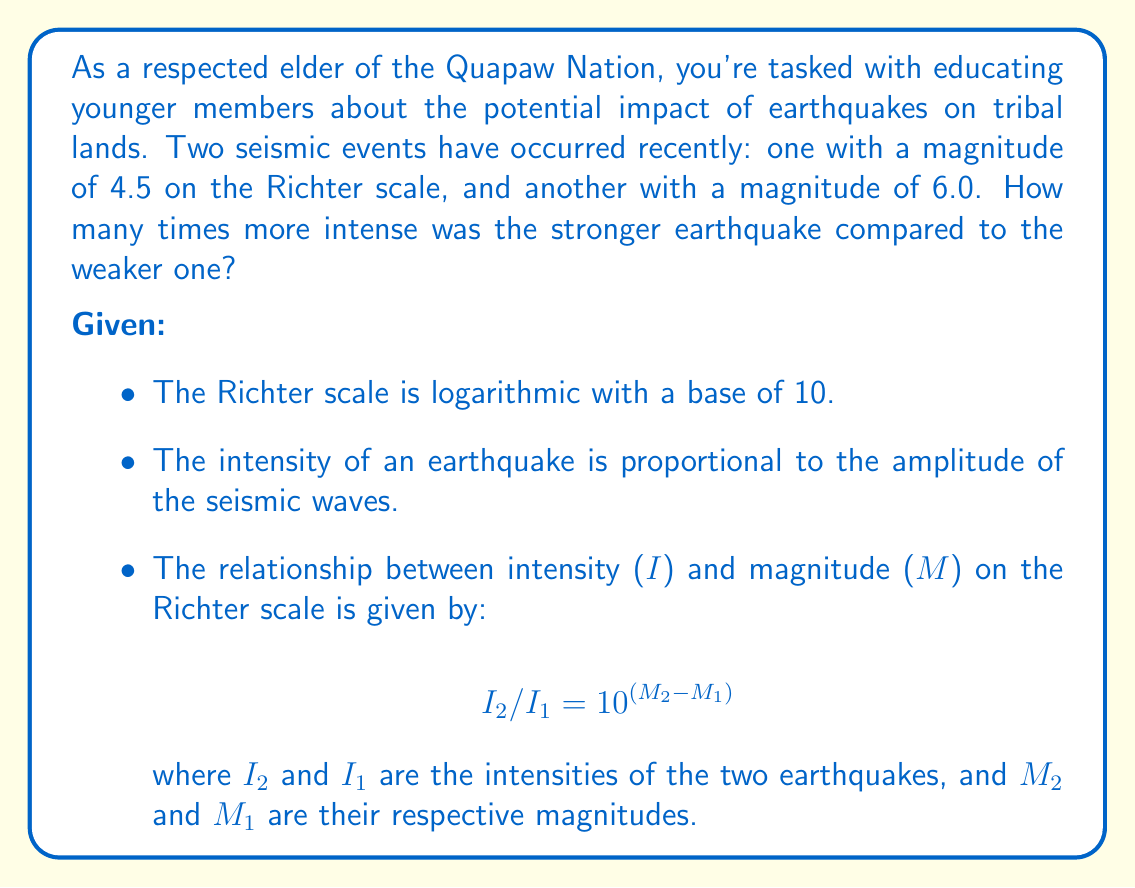Teach me how to tackle this problem. Let's approach this step-by-step:

1) We're given the formula relating intensity to magnitude:

   $$ I_2 / I_1 = 10^{(M_2 - M_1)} $$

2) We know the magnitudes of the two earthquakes:
   $M_1 = 4.5$ (weaker earthquake)
   $M_2 = 6.0$ (stronger earthquake)

3) Let's substitute these values into our equation:

   $$ I_2 / I_1 = 10^{(6.0 - 4.5)} $$

4) Simplify the exponent:

   $$ I_2 / I_1 = 10^{1.5} $$

5) Now, we need to calculate $10^{1.5}$. We can do this using the properties of exponents:

   $$ 10^{1.5} = (10^1) \times (10^{0.5}) = 10 \times \sqrt{10} \approx 31.62 $$

6) Therefore:

   $$ I_2 / I_1 \approx 31.62 $$

This means the stronger earthquake (magnitude 6.0) was approximately 31.62 times more intense than the weaker earthquake (magnitude 4.5).
Answer: The earthquake with a magnitude of 6.0 was approximately 31.62 times more intense than the earthquake with a magnitude of 4.5. 